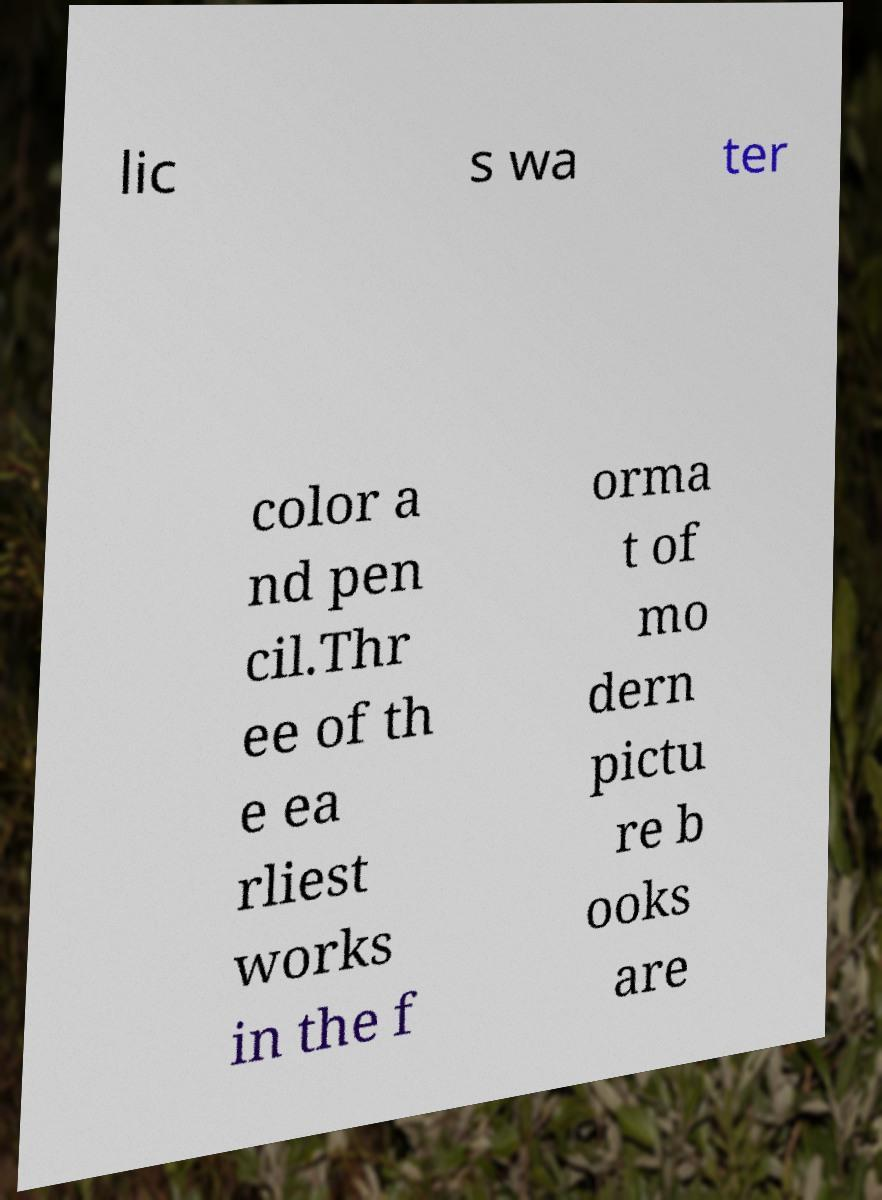Please read and relay the text visible in this image. What does it say? lic s wa ter color a nd pen cil.Thr ee of th e ea rliest works in the f orma t of mo dern pictu re b ooks are 